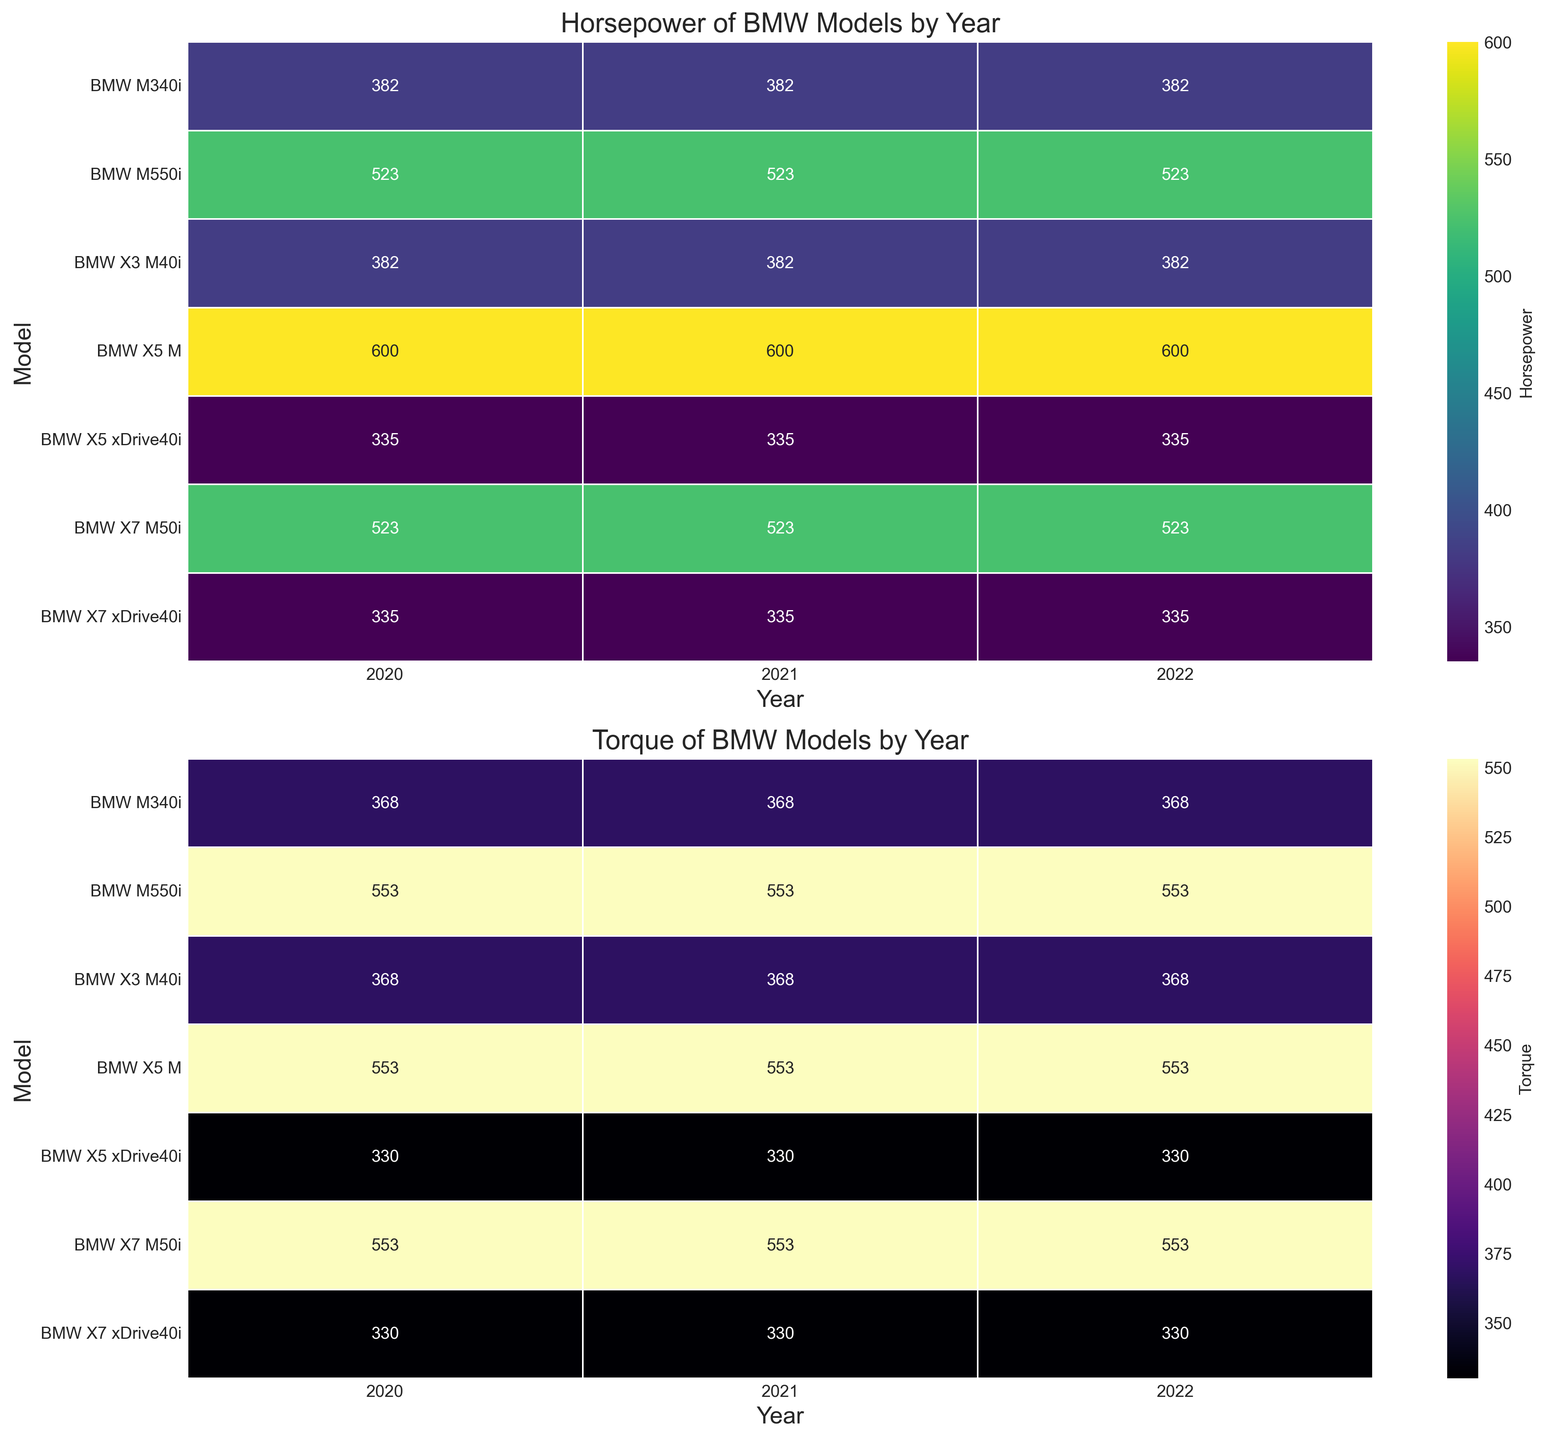Which BMW model has the highest horsepower in 2022? By examining the heatmap for horsepower, locate the column for the year 2022. Identify the model with the highest value in this column. The BMW model with the highest horsepower in 2022 is the BMW X5 M with 600 horsepower.
Answer: BMW X5 M Which BMW model shows the highest torque consistently from 2020 to 2022? Check the heatmap for torque and observe the values from 2020 to 2022. Identify the model with the highest and consistent torque values throughout these years. The BMW X5 M shows the highest torque of 553 across all three years.
Answer: BMW X5 M What is the increase in horsepower from 2020 to 2021 for the BMW M340i? Refer to the heatmap for horsepower and find the values for the BMW M340i in 2020 and 2021. Subtract the 2020 value from the 2021 value. The horsepower remains constant at 382 for both years, so the increase is 382 - 382 = 0.
Answer: 0 Which model has a higher average torque over the three years, BMW X5 M or BMW X7 M50i? Find the torque values for each year for both BMW X5 M and BMW X7 M50i. Average the values for each model, then compare the averages. For BMW X5 M: (553 + 553 + 553)/3 = 553 and for BMW X7 M50i: (553 + 553 + 553)/3 = 553. Both models have the same average torque.
Answer: Both have the same average torque In 2022, which model has higher horsepower, BMW M550i or BMW X7 M50i? Locate the horsepower values for the year 2022 for both BMW M550i and BMW X7 M50i in the heatmap. Compare the values. BMW M550i has a horsepower of 523, and BMW X7 M50i also has 523. They have the same horsepower.
Answer: Both have the same horsepower Is there any year where the BMW X3 M40i has different values of horsepower? Check the columns for each year in the heatmap for horsepower and find the values for the BMW X3 M40i. Verify if the horsepower values differ across 2020 to 2022. The BMW X3 M40i has a constant horsepower of 382 each year.
Answer: No Comparing the year 2020, does BMW X5 xDrive40i have higher torque than BMW X3 M40i? Locate the torque values for 2020 for both BMW X5 xDrive40i and BMW X3 M40i in the heatmap. Compare the values. BMW X5 xDrive40i has a torque of 330, while BMW X3 M40i has 368.
Answer: No Between BMW M340i and BMW X5 M, which model increased more in torque from 2020 to 2021? Check the torque values for both models in 2020 and 2021. For BMW M340i, the torque is 368 in both years, and for BMW X5 M, it is 553 in both years. Neither model has an increase in torque.
Answer: Neither What is the range of horsepower for BMW models in 2022? Locate the horsepower values for different BMW models in 2022 from the heatmap, identify the smallest and largest values, then find the difference. The smallest horsepower is 248 (BMW 530i) and the largest is 600 (BMW X5 M), so the range is 600 - 248.
Answer: 352 